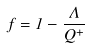<formula> <loc_0><loc_0><loc_500><loc_500>f = 1 - \frac { \Lambda } { Q ^ { + } }</formula> 